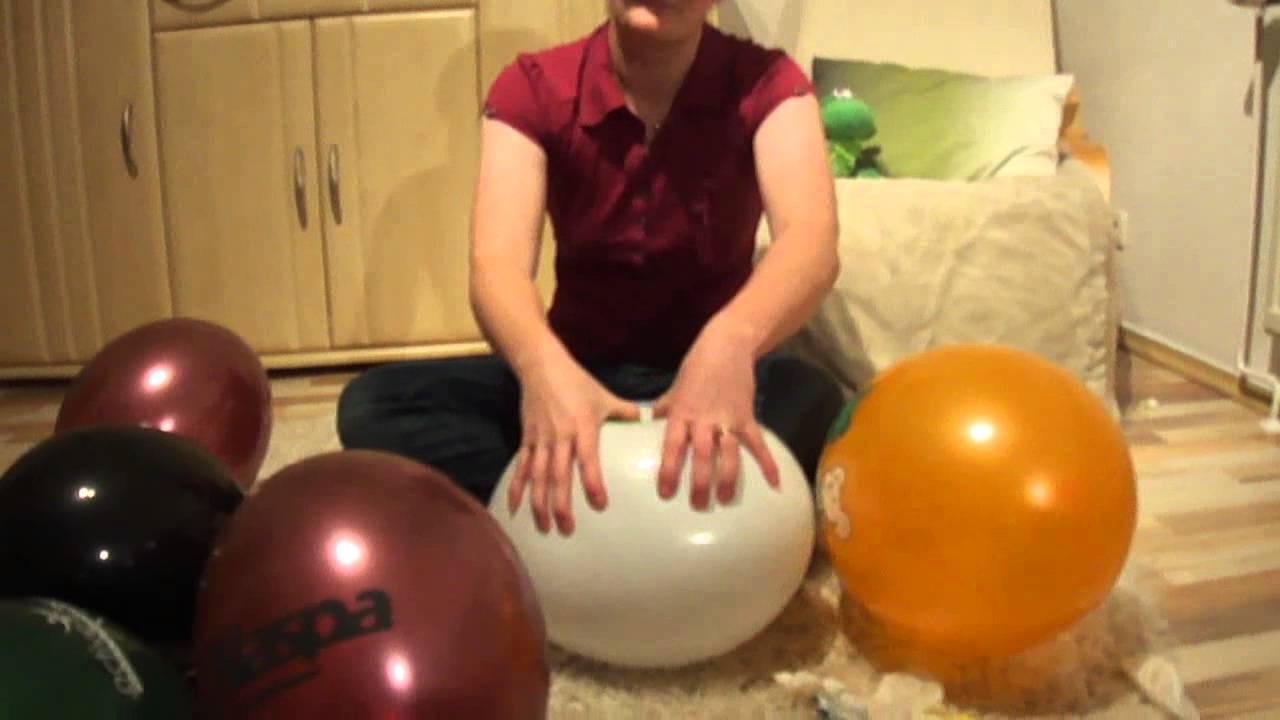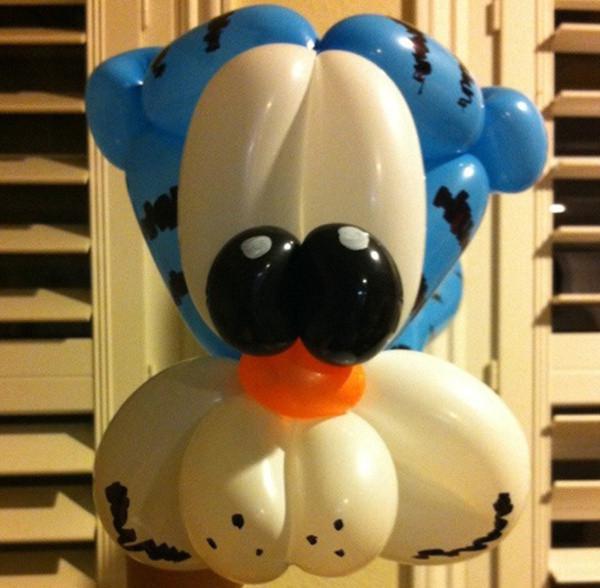The first image is the image on the left, the second image is the image on the right. Considering the images on both sides, is "Exactly one image contains a balloon animal with eyes." valid? Answer yes or no. Yes. 